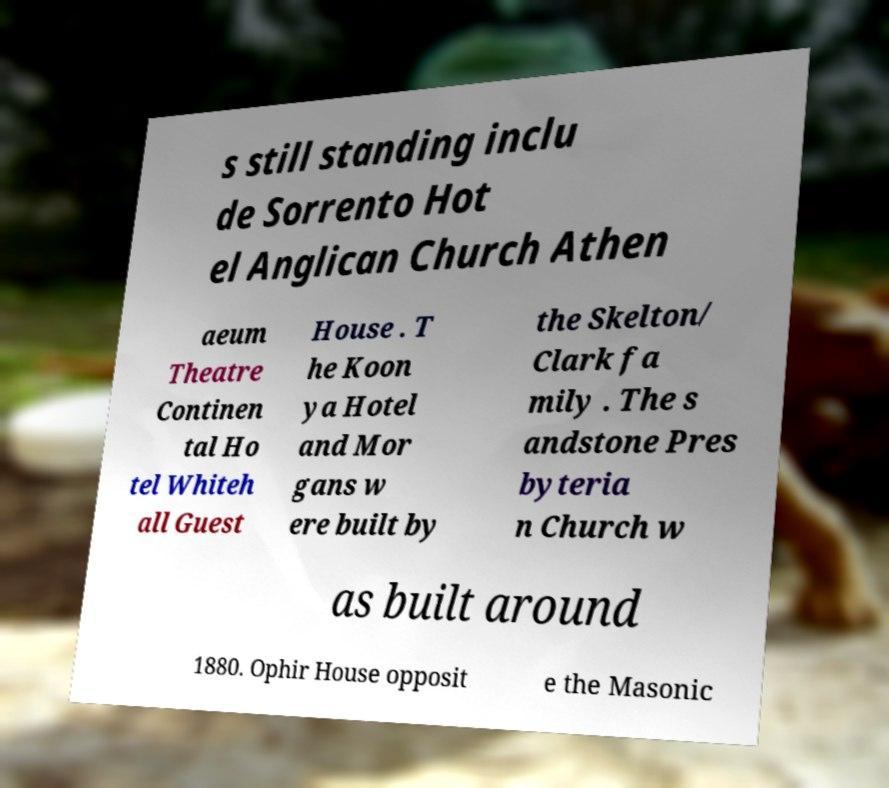Can you accurately transcribe the text from the provided image for me? s still standing inclu de Sorrento Hot el Anglican Church Athen aeum Theatre Continen tal Ho tel Whiteh all Guest House . T he Koon ya Hotel and Mor gans w ere built by the Skelton/ Clark fa mily . The s andstone Pres byteria n Church w as built around 1880. Ophir House opposit e the Masonic 